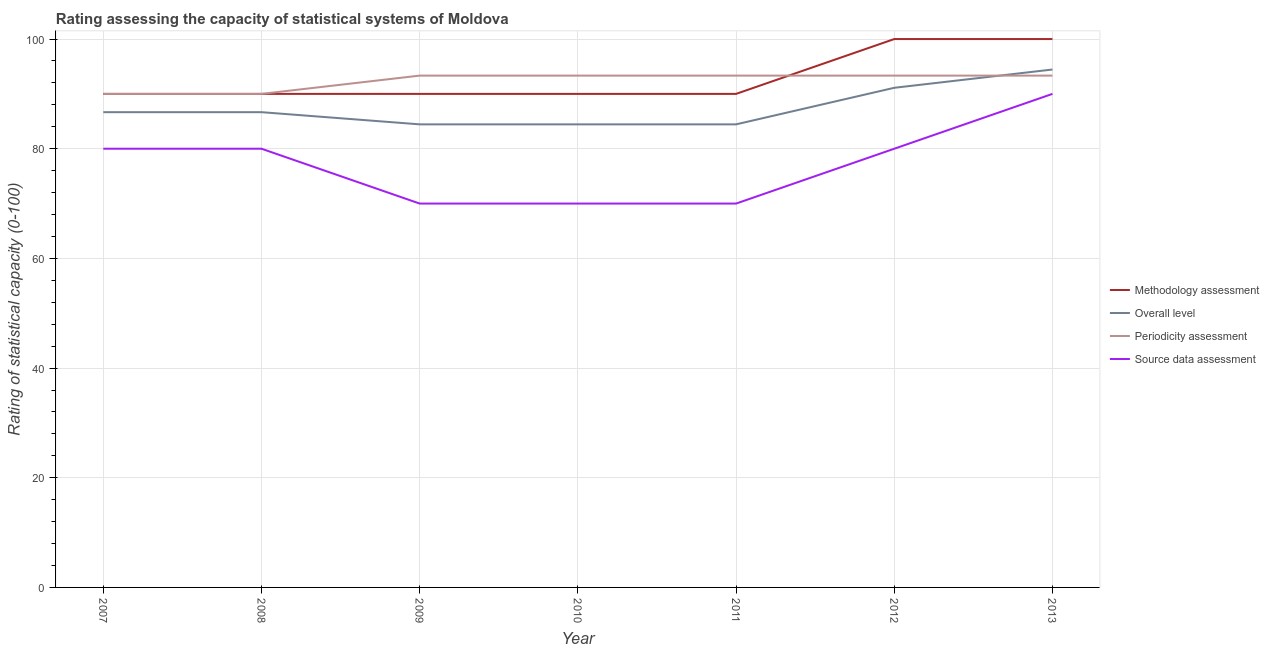How many different coloured lines are there?
Your answer should be compact. 4. What is the periodicity assessment rating in 2012?
Offer a terse response. 93.33. Across all years, what is the maximum periodicity assessment rating?
Ensure brevity in your answer.  93.33. Across all years, what is the minimum methodology assessment rating?
Give a very brief answer. 90. In which year was the overall level rating minimum?
Keep it short and to the point. 2009. What is the total overall level rating in the graph?
Your answer should be very brief. 612.22. What is the difference between the overall level rating in 2007 and the source data assessment rating in 2010?
Give a very brief answer. 16.67. What is the average methodology assessment rating per year?
Provide a succinct answer. 92.86. In the year 2007, what is the difference between the methodology assessment rating and periodicity assessment rating?
Offer a very short reply. 0. What is the ratio of the source data assessment rating in 2008 to that in 2010?
Offer a very short reply. 1.14. Is the methodology assessment rating in 2009 less than that in 2013?
Ensure brevity in your answer.  Yes. Is the difference between the overall level rating in 2007 and 2008 greater than the difference between the periodicity assessment rating in 2007 and 2008?
Keep it short and to the point. No. What is the difference between the highest and the lowest source data assessment rating?
Make the answer very short. 20. In how many years, is the periodicity assessment rating greater than the average periodicity assessment rating taken over all years?
Provide a short and direct response. 5. Is it the case that in every year, the sum of the methodology assessment rating and overall level rating is greater than the periodicity assessment rating?
Provide a short and direct response. Yes. Is the methodology assessment rating strictly greater than the overall level rating over the years?
Provide a succinct answer. Yes. Is the source data assessment rating strictly less than the periodicity assessment rating over the years?
Offer a terse response. Yes. How many years are there in the graph?
Give a very brief answer. 7. Are the values on the major ticks of Y-axis written in scientific E-notation?
Make the answer very short. No. Where does the legend appear in the graph?
Provide a succinct answer. Center right. How many legend labels are there?
Your response must be concise. 4. What is the title of the graph?
Give a very brief answer. Rating assessing the capacity of statistical systems of Moldova. Does "Other greenhouse gases" appear as one of the legend labels in the graph?
Offer a very short reply. No. What is the label or title of the Y-axis?
Your response must be concise. Rating of statistical capacity (0-100). What is the Rating of statistical capacity (0-100) of Overall level in 2007?
Offer a very short reply. 86.67. What is the Rating of statistical capacity (0-100) in Periodicity assessment in 2007?
Make the answer very short. 90. What is the Rating of statistical capacity (0-100) of Source data assessment in 2007?
Make the answer very short. 80. What is the Rating of statistical capacity (0-100) of Methodology assessment in 2008?
Ensure brevity in your answer.  90. What is the Rating of statistical capacity (0-100) in Overall level in 2008?
Keep it short and to the point. 86.67. What is the Rating of statistical capacity (0-100) in Methodology assessment in 2009?
Provide a short and direct response. 90. What is the Rating of statistical capacity (0-100) of Overall level in 2009?
Give a very brief answer. 84.44. What is the Rating of statistical capacity (0-100) in Periodicity assessment in 2009?
Offer a very short reply. 93.33. What is the Rating of statistical capacity (0-100) in Source data assessment in 2009?
Give a very brief answer. 70. What is the Rating of statistical capacity (0-100) in Overall level in 2010?
Provide a short and direct response. 84.44. What is the Rating of statistical capacity (0-100) in Periodicity assessment in 2010?
Your answer should be compact. 93.33. What is the Rating of statistical capacity (0-100) of Source data assessment in 2010?
Offer a very short reply. 70. What is the Rating of statistical capacity (0-100) in Methodology assessment in 2011?
Your answer should be compact. 90. What is the Rating of statistical capacity (0-100) of Overall level in 2011?
Provide a short and direct response. 84.44. What is the Rating of statistical capacity (0-100) of Periodicity assessment in 2011?
Make the answer very short. 93.33. What is the Rating of statistical capacity (0-100) in Overall level in 2012?
Provide a succinct answer. 91.11. What is the Rating of statistical capacity (0-100) in Periodicity assessment in 2012?
Give a very brief answer. 93.33. What is the Rating of statistical capacity (0-100) in Overall level in 2013?
Make the answer very short. 94.44. What is the Rating of statistical capacity (0-100) in Periodicity assessment in 2013?
Provide a short and direct response. 93.33. Across all years, what is the maximum Rating of statistical capacity (0-100) in Overall level?
Ensure brevity in your answer.  94.44. Across all years, what is the maximum Rating of statistical capacity (0-100) of Periodicity assessment?
Your response must be concise. 93.33. Across all years, what is the minimum Rating of statistical capacity (0-100) in Methodology assessment?
Provide a short and direct response. 90. Across all years, what is the minimum Rating of statistical capacity (0-100) in Overall level?
Make the answer very short. 84.44. Across all years, what is the minimum Rating of statistical capacity (0-100) in Periodicity assessment?
Keep it short and to the point. 90. Across all years, what is the minimum Rating of statistical capacity (0-100) of Source data assessment?
Provide a short and direct response. 70. What is the total Rating of statistical capacity (0-100) of Methodology assessment in the graph?
Ensure brevity in your answer.  650. What is the total Rating of statistical capacity (0-100) of Overall level in the graph?
Your response must be concise. 612.22. What is the total Rating of statistical capacity (0-100) of Periodicity assessment in the graph?
Give a very brief answer. 646.67. What is the total Rating of statistical capacity (0-100) in Source data assessment in the graph?
Provide a short and direct response. 540. What is the difference between the Rating of statistical capacity (0-100) in Source data assessment in 2007 and that in 2008?
Give a very brief answer. 0. What is the difference between the Rating of statistical capacity (0-100) in Methodology assessment in 2007 and that in 2009?
Provide a short and direct response. 0. What is the difference between the Rating of statistical capacity (0-100) in Overall level in 2007 and that in 2009?
Keep it short and to the point. 2.22. What is the difference between the Rating of statistical capacity (0-100) of Periodicity assessment in 2007 and that in 2009?
Ensure brevity in your answer.  -3.33. What is the difference between the Rating of statistical capacity (0-100) of Overall level in 2007 and that in 2010?
Ensure brevity in your answer.  2.22. What is the difference between the Rating of statistical capacity (0-100) in Periodicity assessment in 2007 and that in 2010?
Provide a short and direct response. -3.33. What is the difference between the Rating of statistical capacity (0-100) in Overall level in 2007 and that in 2011?
Keep it short and to the point. 2.22. What is the difference between the Rating of statistical capacity (0-100) in Periodicity assessment in 2007 and that in 2011?
Your answer should be compact. -3.33. What is the difference between the Rating of statistical capacity (0-100) in Source data assessment in 2007 and that in 2011?
Give a very brief answer. 10. What is the difference between the Rating of statistical capacity (0-100) of Overall level in 2007 and that in 2012?
Make the answer very short. -4.44. What is the difference between the Rating of statistical capacity (0-100) of Periodicity assessment in 2007 and that in 2012?
Make the answer very short. -3.33. What is the difference between the Rating of statistical capacity (0-100) of Source data assessment in 2007 and that in 2012?
Ensure brevity in your answer.  0. What is the difference between the Rating of statistical capacity (0-100) of Overall level in 2007 and that in 2013?
Provide a short and direct response. -7.78. What is the difference between the Rating of statistical capacity (0-100) in Periodicity assessment in 2007 and that in 2013?
Your answer should be compact. -3.33. What is the difference between the Rating of statistical capacity (0-100) in Overall level in 2008 and that in 2009?
Offer a terse response. 2.22. What is the difference between the Rating of statistical capacity (0-100) in Overall level in 2008 and that in 2010?
Provide a short and direct response. 2.22. What is the difference between the Rating of statistical capacity (0-100) in Source data assessment in 2008 and that in 2010?
Your answer should be very brief. 10. What is the difference between the Rating of statistical capacity (0-100) in Methodology assessment in 2008 and that in 2011?
Your answer should be very brief. 0. What is the difference between the Rating of statistical capacity (0-100) of Overall level in 2008 and that in 2011?
Keep it short and to the point. 2.22. What is the difference between the Rating of statistical capacity (0-100) of Periodicity assessment in 2008 and that in 2011?
Offer a terse response. -3.33. What is the difference between the Rating of statistical capacity (0-100) of Source data assessment in 2008 and that in 2011?
Offer a very short reply. 10. What is the difference between the Rating of statistical capacity (0-100) of Overall level in 2008 and that in 2012?
Ensure brevity in your answer.  -4.44. What is the difference between the Rating of statistical capacity (0-100) in Methodology assessment in 2008 and that in 2013?
Give a very brief answer. -10. What is the difference between the Rating of statistical capacity (0-100) of Overall level in 2008 and that in 2013?
Offer a very short reply. -7.78. What is the difference between the Rating of statistical capacity (0-100) in Periodicity assessment in 2008 and that in 2013?
Provide a succinct answer. -3.33. What is the difference between the Rating of statistical capacity (0-100) of Overall level in 2009 and that in 2011?
Ensure brevity in your answer.  0. What is the difference between the Rating of statistical capacity (0-100) in Source data assessment in 2009 and that in 2011?
Offer a terse response. 0. What is the difference between the Rating of statistical capacity (0-100) in Overall level in 2009 and that in 2012?
Give a very brief answer. -6.67. What is the difference between the Rating of statistical capacity (0-100) of Source data assessment in 2009 and that in 2012?
Provide a short and direct response. -10. What is the difference between the Rating of statistical capacity (0-100) of Methodology assessment in 2009 and that in 2013?
Your response must be concise. -10. What is the difference between the Rating of statistical capacity (0-100) in Overall level in 2009 and that in 2013?
Ensure brevity in your answer.  -10. What is the difference between the Rating of statistical capacity (0-100) in Periodicity assessment in 2009 and that in 2013?
Your answer should be compact. -0. What is the difference between the Rating of statistical capacity (0-100) in Source data assessment in 2009 and that in 2013?
Provide a short and direct response. -20. What is the difference between the Rating of statistical capacity (0-100) of Overall level in 2010 and that in 2011?
Give a very brief answer. 0. What is the difference between the Rating of statistical capacity (0-100) of Periodicity assessment in 2010 and that in 2011?
Keep it short and to the point. 0. What is the difference between the Rating of statistical capacity (0-100) of Source data assessment in 2010 and that in 2011?
Your answer should be very brief. 0. What is the difference between the Rating of statistical capacity (0-100) in Methodology assessment in 2010 and that in 2012?
Offer a very short reply. -10. What is the difference between the Rating of statistical capacity (0-100) of Overall level in 2010 and that in 2012?
Provide a succinct answer. -6.67. What is the difference between the Rating of statistical capacity (0-100) of Periodicity assessment in 2010 and that in 2012?
Your response must be concise. 0. What is the difference between the Rating of statistical capacity (0-100) of Overall level in 2010 and that in 2013?
Your response must be concise. -10. What is the difference between the Rating of statistical capacity (0-100) of Source data assessment in 2010 and that in 2013?
Offer a very short reply. -20. What is the difference between the Rating of statistical capacity (0-100) of Methodology assessment in 2011 and that in 2012?
Keep it short and to the point. -10. What is the difference between the Rating of statistical capacity (0-100) of Overall level in 2011 and that in 2012?
Ensure brevity in your answer.  -6.67. What is the difference between the Rating of statistical capacity (0-100) of Periodicity assessment in 2011 and that in 2012?
Your response must be concise. 0. What is the difference between the Rating of statistical capacity (0-100) in Source data assessment in 2011 and that in 2012?
Offer a very short reply. -10. What is the difference between the Rating of statistical capacity (0-100) in Overall level in 2011 and that in 2013?
Provide a short and direct response. -10. What is the difference between the Rating of statistical capacity (0-100) in Periodicity assessment in 2011 and that in 2013?
Provide a short and direct response. -0. What is the difference between the Rating of statistical capacity (0-100) in Source data assessment in 2011 and that in 2013?
Provide a succinct answer. -20. What is the difference between the Rating of statistical capacity (0-100) in Methodology assessment in 2012 and that in 2013?
Provide a short and direct response. 0. What is the difference between the Rating of statistical capacity (0-100) of Overall level in 2012 and that in 2013?
Give a very brief answer. -3.33. What is the difference between the Rating of statistical capacity (0-100) of Periodicity assessment in 2012 and that in 2013?
Ensure brevity in your answer.  -0. What is the difference between the Rating of statistical capacity (0-100) of Source data assessment in 2012 and that in 2013?
Provide a short and direct response. -10. What is the difference between the Rating of statistical capacity (0-100) of Methodology assessment in 2007 and the Rating of statistical capacity (0-100) of Overall level in 2008?
Keep it short and to the point. 3.33. What is the difference between the Rating of statistical capacity (0-100) of Overall level in 2007 and the Rating of statistical capacity (0-100) of Source data assessment in 2008?
Give a very brief answer. 6.67. What is the difference between the Rating of statistical capacity (0-100) of Methodology assessment in 2007 and the Rating of statistical capacity (0-100) of Overall level in 2009?
Your answer should be compact. 5.56. What is the difference between the Rating of statistical capacity (0-100) in Methodology assessment in 2007 and the Rating of statistical capacity (0-100) in Source data assessment in 2009?
Provide a short and direct response. 20. What is the difference between the Rating of statistical capacity (0-100) of Overall level in 2007 and the Rating of statistical capacity (0-100) of Periodicity assessment in 2009?
Your answer should be compact. -6.67. What is the difference between the Rating of statistical capacity (0-100) of Overall level in 2007 and the Rating of statistical capacity (0-100) of Source data assessment in 2009?
Offer a terse response. 16.67. What is the difference between the Rating of statistical capacity (0-100) in Periodicity assessment in 2007 and the Rating of statistical capacity (0-100) in Source data assessment in 2009?
Your response must be concise. 20. What is the difference between the Rating of statistical capacity (0-100) in Methodology assessment in 2007 and the Rating of statistical capacity (0-100) in Overall level in 2010?
Offer a very short reply. 5.56. What is the difference between the Rating of statistical capacity (0-100) of Methodology assessment in 2007 and the Rating of statistical capacity (0-100) of Source data assessment in 2010?
Your answer should be very brief. 20. What is the difference between the Rating of statistical capacity (0-100) in Overall level in 2007 and the Rating of statistical capacity (0-100) in Periodicity assessment in 2010?
Offer a very short reply. -6.67. What is the difference between the Rating of statistical capacity (0-100) of Overall level in 2007 and the Rating of statistical capacity (0-100) of Source data assessment in 2010?
Your answer should be compact. 16.67. What is the difference between the Rating of statistical capacity (0-100) of Periodicity assessment in 2007 and the Rating of statistical capacity (0-100) of Source data assessment in 2010?
Make the answer very short. 20. What is the difference between the Rating of statistical capacity (0-100) in Methodology assessment in 2007 and the Rating of statistical capacity (0-100) in Overall level in 2011?
Offer a very short reply. 5.56. What is the difference between the Rating of statistical capacity (0-100) in Overall level in 2007 and the Rating of statistical capacity (0-100) in Periodicity assessment in 2011?
Your answer should be compact. -6.67. What is the difference between the Rating of statistical capacity (0-100) in Overall level in 2007 and the Rating of statistical capacity (0-100) in Source data assessment in 2011?
Keep it short and to the point. 16.67. What is the difference between the Rating of statistical capacity (0-100) of Periodicity assessment in 2007 and the Rating of statistical capacity (0-100) of Source data assessment in 2011?
Provide a succinct answer. 20. What is the difference between the Rating of statistical capacity (0-100) of Methodology assessment in 2007 and the Rating of statistical capacity (0-100) of Overall level in 2012?
Your response must be concise. -1.11. What is the difference between the Rating of statistical capacity (0-100) in Methodology assessment in 2007 and the Rating of statistical capacity (0-100) in Source data assessment in 2012?
Provide a short and direct response. 10. What is the difference between the Rating of statistical capacity (0-100) in Overall level in 2007 and the Rating of statistical capacity (0-100) in Periodicity assessment in 2012?
Provide a short and direct response. -6.67. What is the difference between the Rating of statistical capacity (0-100) in Methodology assessment in 2007 and the Rating of statistical capacity (0-100) in Overall level in 2013?
Ensure brevity in your answer.  -4.44. What is the difference between the Rating of statistical capacity (0-100) in Methodology assessment in 2007 and the Rating of statistical capacity (0-100) in Source data assessment in 2013?
Provide a short and direct response. 0. What is the difference between the Rating of statistical capacity (0-100) in Overall level in 2007 and the Rating of statistical capacity (0-100) in Periodicity assessment in 2013?
Give a very brief answer. -6.67. What is the difference between the Rating of statistical capacity (0-100) of Periodicity assessment in 2007 and the Rating of statistical capacity (0-100) of Source data assessment in 2013?
Your answer should be compact. 0. What is the difference between the Rating of statistical capacity (0-100) in Methodology assessment in 2008 and the Rating of statistical capacity (0-100) in Overall level in 2009?
Provide a succinct answer. 5.56. What is the difference between the Rating of statistical capacity (0-100) in Methodology assessment in 2008 and the Rating of statistical capacity (0-100) in Periodicity assessment in 2009?
Your response must be concise. -3.33. What is the difference between the Rating of statistical capacity (0-100) of Methodology assessment in 2008 and the Rating of statistical capacity (0-100) of Source data assessment in 2009?
Give a very brief answer. 20. What is the difference between the Rating of statistical capacity (0-100) in Overall level in 2008 and the Rating of statistical capacity (0-100) in Periodicity assessment in 2009?
Offer a terse response. -6.67. What is the difference between the Rating of statistical capacity (0-100) in Overall level in 2008 and the Rating of statistical capacity (0-100) in Source data assessment in 2009?
Provide a short and direct response. 16.67. What is the difference between the Rating of statistical capacity (0-100) in Periodicity assessment in 2008 and the Rating of statistical capacity (0-100) in Source data assessment in 2009?
Offer a terse response. 20. What is the difference between the Rating of statistical capacity (0-100) in Methodology assessment in 2008 and the Rating of statistical capacity (0-100) in Overall level in 2010?
Ensure brevity in your answer.  5.56. What is the difference between the Rating of statistical capacity (0-100) of Methodology assessment in 2008 and the Rating of statistical capacity (0-100) of Periodicity assessment in 2010?
Offer a very short reply. -3.33. What is the difference between the Rating of statistical capacity (0-100) in Overall level in 2008 and the Rating of statistical capacity (0-100) in Periodicity assessment in 2010?
Keep it short and to the point. -6.67. What is the difference between the Rating of statistical capacity (0-100) in Overall level in 2008 and the Rating of statistical capacity (0-100) in Source data assessment in 2010?
Keep it short and to the point. 16.67. What is the difference between the Rating of statistical capacity (0-100) of Methodology assessment in 2008 and the Rating of statistical capacity (0-100) of Overall level in 2011?
Keep it short and to the point. 5.56. What is the difference between the Rating of statistical capacity (0-100) of Overall level in 2008 and the Rating of statistical capacity (0-100) of Periodicity assessment in 2011?
Offer a terse response. -6.67. What is the difference between the Rating of statistical capacity (0-100) in Overall level in 2008 and the Rating of statistical capacity (0-100) in Source data assessment in 2011?
Ensure brevity in your answer.  16.67. What is the difference between the Rating of statistical capacity (0-100) of Periodicity assessment in 2008 and the Rating of statistical capacity (0-100) of Source data assessment in 2011?
Keep it short and to the point. 20. What is the difference between the Rating of statistical capacity (0-100) in Methodology assessment in 2008 and the Rating of statistical capacity (0-100) in Overall level in 2012?
Ensure brevity in your answer.  -1.11. What is the difference between the Rating of statistical capacity (0-100) of Methodology assessment in 2008 and the Rating of statistical capacity (0-100) of Source data assessment in 2012?
Offer a terse response. 10. What is the difference between the Rating of statistical capacity (0-100) of Overall level in 2008 and the Rating of statistical capacity (0-100) of Periodicity assessment in 2012?
Make the answer very short. -6.67. What is the difference between the Rating of statistical capacity (0-100) in Overall level in 2008 and the Rating of statistical capacity (0-100) in Source data assessment in 2012?
Offer a terse response. 6.67. What is the difference between the Rating of statistical capacity (0-100) in Methodology assessment in 2008 and the Rating of statistical capacity (0-100) in Overall level in 2013?
Offer a terse response. -4.44. What is the difference between the Rating of statistical capacity (0-100) of Methodology assessment in 2008 and the Rating of statistical capacity (0-100) of Periodicity assessment in 2013?
Offer a very short reply. -3.33. What is the difference between the Rating of statistical capacity (0-100) of Overall level in 2008 and the Rating of statistical capacity (0-100) of Periodicity assessment in 2013?
Your answer should be compact. -6.67. What is the difference between the Rating of statistical capacity (0-100) of Overall level in 2008 and the Rating of statistical capacity (0-100) of Source data assessment in 2013?
Provide a succinct answer. -3.33. What is the difference between the Rating of statistical capacity (0-100) of Methodology assessment in 2009 and the Rating of statistical capacity (0-100) of Overall level in 2010?
Offer a terse response. 5.56. What is the difference between the Rating of statistical capacity (0-100) in Methodology assessment in 2009 and the Rating of statistical capacity (0-100) in Periodicity assessment in 2010?
Provide a succinct answer. -3.33. What is the difference between the Rating of statistical capacity (0-100) of Methodology assessment in 2009 and the Rating of statistical capacity (0-100) of Source data assessment in 2010?
Your answer should be compact. 20. What is the difference between the Rating of statistical capacity (0-100) of Overall level in 2009 and the Rating of statistical capacity (0-100) of Periodicity assessment in 2010?
Your response must be concise. -8.89. What is the difference between the Rating of statistical capacity (0-100) in Overall level in 2009 and the Rating of statistical capacity (0-100) in Source data assessment in 2010?
Provide a short and direct response. 14.44. What is the difference between the Rating of statistical capacity (0-100) of Periodicity assessment in 2009 and the Rating of statistical capacity (0-100) of Source data assessment in 2010?
Give a very brief answer. 23.33. What is the difference between the Rating of statistical capacity (0-100) in Methodology assessment in 2009 and the Rating of statistical capacity (0-100) in Overall level in 2011?
Ensure brevity in your answer.  5.56. What is the difference between the Rating of statistical capacity (0-100) in Methodology assessment in 2009 and the Rating of statistical capacity (0-100) in Periodicity assessment in 2011?
Offer a terse response. -3.33. What is the difference between the Rating of statistical capacity (0-100) of Overall level in 2009 and the Rating of statistical capacity (0-100) of Periodicity assessment in 2011?
Ensure brevity in your answer.  -8.89. What is the difference between the Rating of statistical capacity (0-100) in Overall level in 2009 and the Rating of statistical capacity (0-100) in Source data assessment in 2011?
Offer a very short reply. 14.44. What is the difference between the Rating of statistical capacity (0-100) of Periodicity assessment in 2009 and the Rating of statistical capacity (0-100) of Source data assessment in 2011?
Offer a very short reply. 23.33. What is the difference between the Rating of statistical capacity (0-100) in Methodology assessment in 2009 and the Rating of statistical capacity (0-100) in Overall level in 2012?
Provide a short and direct response. -1.11. What is the difference between the Rating of statistical capacity (0-100) of Methodology assessment in 2009 and the Rating of statistical capacity (0-100) of Periodicity assessment in 2012?
Your response must be concise. -3.33. What is the difference between the Rating of statistical capacity (0-100) in Methodology assessment in 2009 and the Rating of statistical capacity (0-100) in Source data assessment in 2012?
Provide a succinct answer. 10. What is the difference between the Rating of statistical capacity (0-100) in Overall level in 2009 and the Rating of statistical capacity (0-100) in Periodicity assessment in 2012?
Provide a short and direct response. -8.89. What is the difference between the Rating of statistical capacity (0-100) of Overall level in 2009 and the Rating of statistical capacity (0-100) of Source data assessment in 2012?
Provide a short and direct response. 4.44. What is the difference between the Rating of statistical capacity (0-100) in Periodicity assessment in 2009 and the Rating of statistical capacity (0-100) in Source data assessment in 2012?
Keep it short and to the point. 13.33. What is the difference between the Rating of statistical capacity (0-100) in Methodology assessment in 2009 and the Rating of statistical capacity (0-100) in Overall level in 2013?
Offer a very short reply. -4.44. What is the difference between the Rating of statistical capacity (0-100) of Methodology assessment in 2009 and the Rating of statistical capacity (0-100) of Periodicity assessment in 2013?
Offer a terse response. -3.33. What is the difference between the Rating of statistical capacity (0-100) of Methodology assessment in 2009 and the Rating of statistical capacity (0-100) of Source data assessment in 2013?
Provide a short and direct response. 0. What is the difference between the Rating of statistical capacity (0-100) of Overall level in 2009 and the Rating of statistical capacity (0-100) of Periodicity assessment in 2013?
Make the answer very short. -8.89. What is the difference between the Rating of statistical capacity (0-100) of Overall level in 2009 and the Rating of statistical capacity (0-100) of Source data assessment in 2013?
Your response must be concise. -5.56. What is the difference between the Rating of statistical capacity (0-100) of Periodicity assessment in 2009 and the Rating of statistical capacity (0-100) of Source data assessment in 2013?
Make the answer very short. 3.33. What is the difference between the Rating of statistical capacity (0-100) in Methodology assessment in 2010 and the Rating of statistical capacity (0-100) in Overall level in 2011?
Your answer should be compact. 5.56. What is the difference between the Rating of statistical capacity (0-100) in Methodology assessment in 2010 and the Rating of statistical capacity (0-100) in Source data assessment in 2011?
Keep it short and to the point. 20. What is the difference between the Rating of statistical capacity (0-100) in Overall level in 2010 and the Rating of statistical capacity (0-100) in Periodicity assessment in 2011?
Your answer should be very brief. -8.89. What is the difference between the Rating of statistical capacity (0-100) in Overall level in 2010 and the Rating of statistical capacity (0-100) in Source data assessment in 2011?
Your response must be concise. 14.44. What is the difference between the Rating of statistical capacity (0-100) in Periodicity assessment in 2010 and the Rating of statistical capacity (0-100) in Source data assessment in 2011?
Your answer should be very brief. 23.33. What is the difference between the Rating of statistical capacity (0-100) of Methodology assessment in 2010 and the Rating of statistical capacity (0-100) of Overall level in 2012?
Your answer should be very brief. -1.11. What is the difference between the Rating of statistical capacity (0-100) in Overall level in 2010 and the Rating of statistical capacity (0-100) in Periodicity assessment in 2012?
Offer a terse response. -8.89. What is the difference between the Rating of statistical capacity (0-100) in Overall level in 2010 and the Rating of statistical capacity (0-100) in Source data assessment in 2012?
Your response must be concise. 4.44. What is the difference between the Rating of statistical capacity (0-100) in Periodicity assessment in 2010 and the Rating of statistical capacity (0-100) in Source data assessment in 2012?
Your answer should be compact. 13.33. What is the difference between the Rating of statistical capacity (0-100) of Methodology assessment in 2010 and the Rating of statistical capacity (0-100) of Overall level in 2013?
Your response must be concise. -4.44. What is the difference between the Rating of statistical capacity (0-100) in Overall level in 2010 and the Rating of statistical capacity (0-100) in Periodicity assessment in 2013?
Offer a terse response. -8.89. What is the difference between the Rating of statistical capacity (0-100) of Overall level in 2010 and the Rating of statistical capacity (0-100) of Source data assessment in 2013?
Give a very brief answer. -5.56. What is the difference between the Rating of statistical capacity (0-100) in Methodology assessment in 2011 and the Rating of statistical capacity (0-100) in Overall level in 2012?
Offer a terse response. -1.11. What is the difference between the Rating of statistical capacity (0-100) of Methodology assessment in 2011 and the Rating of statistical capacity (0-100) of Periodicity assessment in 2012?
Your answer should be compact. -3.33. What is the difference between the Rating of statistical capacity (0-100) in Overall level in 2011 and the Rating of statistical capacity (0-100) in Periodicity assessment in 2012?
Offer a very short reply. -8.89. What is the difference between the Rating of statistical capacity (0-100) of Overall level in 2011 and the Rating of statistical capacity (0-100) of Source data assessment in 2012?
Your answer should be very brief. 4.44. What is the difference between the Rating of statistical capacity (0-100) in Periodicity assessment in 2011 and the Rating of statistical capacity (0-100) in Source data assessment in 2012?
Your answer should be compact. 13.33. What is the difference between the Rating of statistical capacity (0-100) of Methodology assessment in 2011 and the Rating of statistical capacity (0-100) of Overall level in 2013?
Offer a very short reply. -4.44. What is the difference between the Rating of statistical capacity (0-100) of Methodology assessment in 2011 and the Rating of statistical capacity (0-100) of Periodicity assessment in 2013?
Offer a very short reply. -3.33. What is the difference between the Rating of statistical capacity (0-100) in Overall level in 2011 and the Rating of statistical capacity (0-100) in Periodicity assessment in 2013?
Give a very brief answer. -8.89. What is the difference between the Rating of statistical capacity (0-100) in Overall level in 2011 and the Rating of statistical capacity (0-100) in Source data assessment in 2013?
Give a very brief answer. -5.56. What is the difference between the Rating of statistical capacity (0-100) in Methodology assessment in 2012 and the Rating of statistical capacity (0-100) in Overall level in 2013?
Provide a short and direct response. 5.56. What is the difference between the Rating of statistical capacity (0-100) in Methodology assessment in 2012 and the Rating of statistical capacity (0-100) in Source data assessment in 2013?
Offer a very short reply. 10. What is the difference between the Rating of statistical capacity (0-100) in Overall level in 2012 and the Rating of statistical capacity (0-100) in Periodicity assessment in 2013?
Keep it short and to the point. -2.22. What is the difference between the Rating of statistical capacity (0-100) in Overall level in 2012 and the Rating of statistical capacity (0-100) in Source data assessment in 2013?
Provide a succinct answer. 1.11. What is the average Rating of statistical capacity (0-100) of Methodology assessment per year?
Provide a short and direct response. 92.86. What is the average Rating of statistical capacity (0-100) in Overall level per year?
Make the answer very short. 87.46. What is the average Rating of statistical capacity (0-100) in Periodicity assessment per year?
Ensure brevity in your answer.  92.38. What is the average Rating of statistical capacity (0-100) in Source data assessment per year?
Give a very brief answer. 77.14. In the year 2007, what is the difference between the Rating of statistical capacity (0-100) in Methodology assessment and Rating of statistical capacity (0-100) in Overall level?
Offer a very short reply. 3.33. In the year 2007, what is the difference between the Rating of statistical capacity (0-100) of Methodology assessment and Rating of statistical capacity (0-100) of Periodicity assessment?
Provide a succinct answer. 0. In the year 2007, what is the difference between the Rating of statistical capacity (0-100) of Methodology assessment and Rating of statistical capacity (0-100) of Source data assessment?
Make the answer very short. 10. In the year 2007, what is the difference between the Rating of statistical capacity (0-100) in Overall level and Rating of statistical capacity (0-100) in Periodicity assessment?
Offer a very short reply. -3.33. In the year 2007, what is the difference between the Rating of statistical capacity (0-100) in Periodicity assessment and Rating of statistical capacity (0-100) in Source data assessment?
Your answer should be compact. 10. In the year 2008, what is the difference between the Rating of statistical capacity (0-100) in Methodology assessment and Rating of statistical capacity (0-100) in Overall level?
Give a very brief answer. 3.33. In the year 2008, what is the difference between the Rating of statistical capacity (0-100) of Overall level and Rating of statistical capacity (0-100) of Periodicity assessment?
Your answer should be compact. -3.33. In the year 2008, what is the difference between the Rating of statistical capacity (0-100) in Overall level and Rating of statistical capacity (0-100) in Source data assessment?
Provide a succinct answer. 6.67. In the year 2009, what is the difference between the Rating of statistical capacity (0-100) of Methodology assessment and Rating of statistical capacity (0-100) of Overall level?
Give a very brief answer. 5.56. In the year 2009, what is the difference between the Rating of statistical capacity (0-100) in Methodology assessment and Rating of statistical capacity (0-100) in Periodicity assessment?
Your answer should be compact. -3.33. In the year 2009, what is the difference between the Rating of statistical capacity (0-100) of Overall level and Rating of statistical capacity (0-100) of Periodicity assessment?
Provide a short and direct response. -8.89. In the year 2009, what is the difference between the Rating of statistical capacity (0-100) in Overall level and Rating of statistical capacity (0-100) in Source data assessment?
Your response must be concise. 14.44. In the year 2009, what is the difference between the Rating of statistical capacity (0-100) in Periodicity assessment and Rating of statistical capacity (0-100) in Source data assessment?
Offer a very short reply. 23.33. In the year 2010, what is the difference between the Rating of statistical capacity (0-100) of Methodology assessment and Rating of statistical capacity (0-100) of Overall level?
Provide a short and direct response. 5.56. In the year 2010, what is the difference between the Rating of statistical capacity (0-100) of Overall level and Rating of statistical capacity (0-100) of Periodicity assessment?
Keep it short and to the point. -8.89. In the year 2010, what is the difference between the Rating of statistical capacity (0-100) of Overall level and Rating of statistical capacity (0-100) of Source data assessment?
Provide a short and direct response. 14.44. In the year 2010, what is the difference between the Rating of statistical capacity (0-100) in Periodicity assessment and Rating of statistical capacity (0-100) in Source data assessment?
Provide a succinct answer. 23.33. In the year 2011, what is the difference between the Rating of statistical capacity (0-100) of Methodology assessment and Rating of statistical capacity (0-100) of Overall level?
Keep it short and to the point. 5.56. In the year 2011, what is the difference between the Rating of statistical capacity (0-100) in Overall level and Rating of statistical capacity (0-100) in Periodicity assessment?
Keep it short and to the point. -8.89. In the year 2011, what is the difference between the Rating of statistical capacity (0-100) in Overall level and Rating of statistical capacity (0-100) in Source data assessment?
Provide a succinct answer. 14.44. In the year 2011, what is the difference between the Rating of statistical capacity (0-100) of Periodicity assessment and Rating of statistical capacity (0-100) of Source data assessment?
Ensure brevity in your answer.  23.33. In the year 2012, what is the difference between the Rating of statistical capacity (0-100) of Methodology assessment and Rating of statistical capacity (0-100) of Overall level?
Your response must be concise. 8.89. In the year 2012, what is the difference between the Rating of statistical capacity (0-100) in Methodology assessment and Rating of statistical capacity (0-100) in Source data assessment?
Make the answer very short. 20. In the year 2012, what is the difference between the Rating of statistical capacity (0-100) in Overall level and Rating of statistical capacity (0-100) in Periodicity assessment?
Your answer should be very brief. -2.22. In the year 2012, what is the difference between the Rating of statistical capacity (0-100) of Overall level and Rating of statistical capacity (0-100) of Source data assessment?
Give a very brief answer. 11.11. In the year 2012, what is the difference between the Rating of statistical capacity (0-100) of Periodicity assessment and Rating of statistical capacity (0-100) of Source data assessment?
Your response must be concise. 13.33. In the year 2013, what is the difference between the Rating of statistical capacity (0-100) of Methodology assessment and Rating of statistical capacity (0-100) of Overall level?
Your answer should be compact. 5.56. In the year 2013, what is the difference between the Rating of statistical capacity (0-100) in Methodology assessment and Rating of statistical capacity (0-100) in Periodicity assessment?
Make the answer very short. 6.67. In the year 2013, what is the difference between the Rating of statistical capacity (0-100) of Overall level and Rating of statistical capacity (0-100) of Periodicity assessment?
Your response must be concise. 1.11. In the year 2013, what is the difference between the Rating of statistical capacity (0-100) in Overall level and Rating of statistical capacity (0-100) in Source data assessment?
Offer a very short reply. 4.44. In the year 2013, what is the difference between the Rating of statistical capacity (0-100) in Periodicity assessment and Rating of statistical capacity (0-100) in Source data assessment?
Your answer should be very brief. 3.33. What is the ratio of the Rating of statistical capacity (0-100) in Methodology assessment in 2007 to that in 2008?
Keep it short and to the point. 1. What is the ratio of the Rating of statistical capacity (0-100) in Overall level in 2007 to that in 2008?
Offer a very short reply. 1. What is the ratio of the Rating of statistical capacity (0-100) in Periodicity assessment in 2007 to that in 2008?
Ensure brevity in your answer.  1. What is the ratio of the Rating of statistical capacity (0-100) in Source data assessment in 2007 to that in 2008?
Offer a terse response. 1. What is the ratio of the Rating of statistical capacity (0-100) of Overall level in 2007 to that in 2009?
Your answer should be very brief. 1.03. What is the ratio of the Rating of statistical capacity (0-100) of Source data assessment in 2007 to that in 2009?
Your answer should be very brief. 1.14. What is the ratio of the Rating of statistical capacity (0-100) of Methodology assessment in 2007 to that in 2010?
Offer a terse response. 1. What is the ratio of the Rating of statistical capacity (0-100) of Overall level in 2007 to that in 2010?
Provide a short and direct response. 1.03. What is the ratio of the Rating of statistical capacity (0-100) of Source data assessment in 2007 to that in 2010?
Keep it short and to the point. 1.14. What is the ratio of the Rating of statistical capacity (0-100) of Methodology assessment in 2007 to that in 2011?
Keep it short and to the point. 1. What is the ratio of the Rating of statistical capacity (0-100) of Overall level in 2007 to that in 2011?
Give a very brief answer. 1.03. What is the ratio of the Rating of statistical capacity (0-100) in Overall level in 2007 to that in 2012?
Your answer should be compact. 0.95. What is the ratio of the Rating of statistical capacity (0-100) in Source data assessment in 2007 to that in 2012?
Offer a terse response. 1. What is the ratio of the Rating of statistical capacity (0-100) in Methodology assessment in 2007 to that in 2013?
Make the answer very short. 0.9. What is the ratio of the Rating of statistical capacity (0-100) in Overall level in 2007 to that in 2013?
Your response must be concise. 0.92. What is the ratio of the Rating of statistical capacity (0-100) of Periodicity assessment in 2007 to that in 2013?
Offer a very short reply. 0.96. What is the ratio of the Rating of statistical capacity (0-100) in Methodology assessment in 2008 to that in 2009?
Keep it short and to the point. 1. What is the ratio of the Rating of statistical capacity (0-100) of Overall level in 2008 to that in 2009?
Your answer should be compact. 1.03. What is the ratio of the Rating of statistical capacity (0-100) of Source data assessment in 2008 to that in 2009?
Keep it short and to the point. 1.14. What is the ratio of the Rating of statistical capacity (0-100) of Overall level in 2008 to that in 2010?
Give a very brief answer. 1.03. What is the ratio of the Rating of statistical capacity (0-100) in Periodicity assessment in 2008 to that in 2010?
Offer a very short reply. 0.96. What is the ratio of the Rating of statistical capacity (0-100) of Overall level in 2008 to that in 2011?
Your response must be concise. 1.03. What is the ratio of the Rating of statistical capacity (0-100) in Methodology assessment in 2008 to that in 2012?
Give a very brief answer. 0.9. What is the ratio of the Rating of statistical capacity (0-100) of Overall level in 2008 to that in 2012?
Offer a very short reply. 0.95. What is the ratio of the Rating of statistical capacity (0-100) in Source data assessment in 2008 to that in 2012?
Ensure brevity in your answer.  1. What is the ratio of the Rating of statistical capacity (0-100) in Overall level in 2008 to that in 2013?
Provide a short and direct response. 0.92. What is the ratio of the Rating of statistical capacity (0-100) of Periodicity assessment in 2008 to that in 2013?
Offer a terse response. 0.96. What is the ratio of the Rating of statistical capacity (0-100) of Periodicity assessment in 2009 to that in 2010?
Ensure brevity in your answer.  1. What is the ratio of the Rating of statistical capacity (0-100) of Source data assessment in 2009 to that in 2010?
Ensure brevity in your answer.  1. What is the ratio of the Rating of statistical capacity (0-100) of Methodology assessment in 2009 to that in 2011?
Your answer should be very brief. 1. What is the ratio of the Rating of statistical capacity (0-100) in Source data assessment in 2009 to that in 2011?
Ensure brevity in your answer.  1. What is the ratio of the Rating of statistical capacity (0-100) of Overall level in 2009 to that in 2012?
Your answer should be compact. 0.93. What is the ratio of the Rating of statistical capacity (0-100) of Methodology assessment in 2009 to that in 2013?
Your answer should be compact. 0.9. What is the ratio of the Rating of statistical capacity (0-100) of Overall level in 2009 to that in 2013?
Make the answer very short. 0.89. What is the ratio of the Rating of statistical capacity (0-100) of Periodicity assessment in 2009 to that in 2013?
Provide a succinct answer. 1. What is the ratio of the Rating of statistical capacity (0-100) of Overall level in 2010 to that in 2011?
Provide a succinct answer. 1. What is the ratio of the Rating of statistical capacity (0-100) in Methodology assessment in 2010 to that in 2012?
Your answer should be compact. 0.9. What is the ratio of the Rating of statistical capacity (0-100) in Overall level in 2010 to that in 2012?
Offer a very short reply. 0.93. What is the ratio of the Rating of statistical capacity (0-100) of Overall level in 2010 to that in 2013?
Ensure brevity in your answer.  0.89. What is the ratio of the Rating of statistical capacity (0-100) of Source data assessment in 2010 to that in 2013?
Your answer should be compact. 0.78. What is the ratio of the Rating of statistical capacity (0-100) in Overall level in 2011 to that in 2012?
Offer a very short reply. 0.93. What is the ratio of the Rating of statistical capacity (0-100) in Source data assessment in 2011 to that in 2012?
Offer a very short reply. 0.88. What is the ratio of the Rating of statistical capacity (0-100) of Methodology assessment in 2011 to that in 2013?
Make the answer very short. 0.9. What is the ratio of the Rating of statistical capacity (0-100) of Overall level in 2011 to that in 2013?
Provide a succinct answer. 0.89. What is the ratio of the Rating of statistical capacity (0-100) of Methodology assessment in 2012 to that in 2013?
Offer a terse response. 1. What is the ratio of the Rating of statistical capacity (0-100) of Overall level in 2012 to that in 2013?
Offer a very short reply. 0.96. What is the ratio of the Rating of statistical capacity (0-100) of Periodicity assessment in 2012 to that in 2013?
Ensure brevity in your answer.  1. What is the difference between the highest and the second highest Rating of statistical capacity (0-100) in Methodology assessment?
Your answer should be very brief. 0. What is the difference between the highest and the second highest Rating of statistical capacity (0-100) in Overall level?
Ensure brevity in your answer.  3.33. What is the difference between the highest and the second highest Rating of statistical capacity (0-100) in Periodicity assessment?
Keep it short and to the point. 0. 